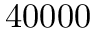Convert formula to latex. <formula><loc_0><loc_0><loc_500><loc_500>4 0 0 0 0</formula> 